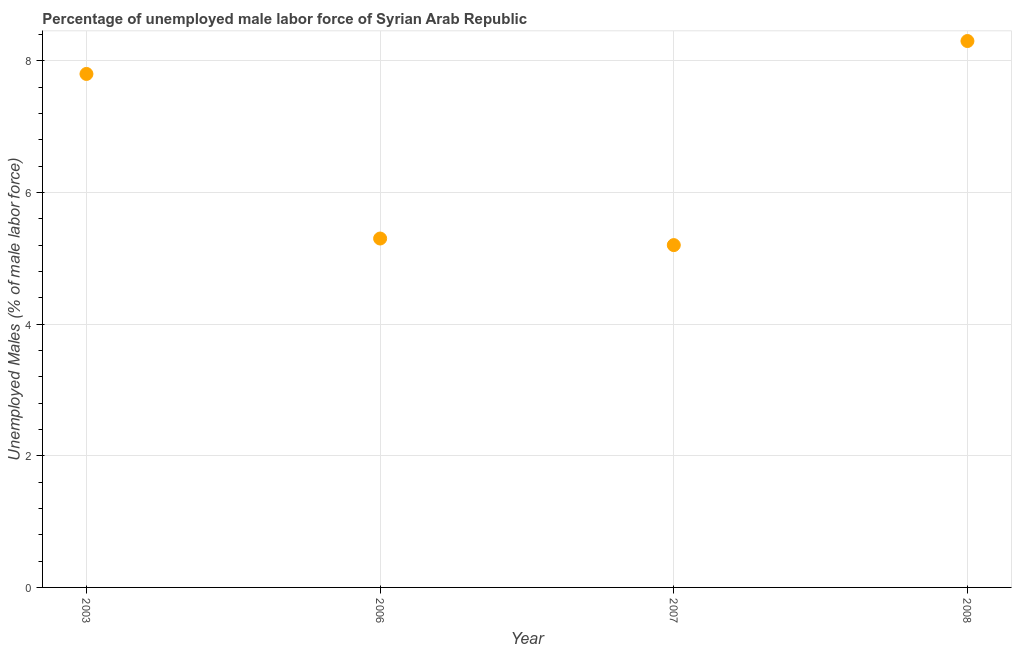What is the total unemployed male labour force in 2008?
Provide a short and direct response. 8.3. Across all years, what is the maximum total unemployed male labour force?
Keep it short and to the point. 8.3. Across all years, what is the minimum total unemployed male labour force?
Ensure brevity in your answer.  5.2. In which year was the total unemployed male labour force maximum?
Keep it short and to the point. 2008. In which year was the total unemployed male labour force minimum?
Give a very brief answer. 2007. What is the sum of the total unemployed male labour force?
Ensure brevity in your answer.  26.6. What is the difference between the total unemployed male labour force in 2003 and 2007?
Your answer should be compact. 2.6. What is the average total unemployed male labour force per year?
Give a very brief answer. 6.65. What is the median total unemployed male labour force?
Give a very brief answer. 6.55. What is the ratio of the total unemployed male labour force in 2006 to that in 2008?
Your answer should be compact. 0.64. What is the difference between the highest and the second highest total unemployed male labour force?
Your response must be concise. 0.5. What is the difference between the highest and the lowest total unemployed male labour force?
Ensure brevity in your answer.  3.1. In how many years, is the total unemployed male labour force greater than the average total unemployed male labour force taken over all years?
Keep it short and to the point. 2. How many dotlines are there?
Provide a succinct answer. 1. What is the difference between two consecutive major ticks on the Y-axis?
Ensure brevity in your answer.  2. Does the graph contain grids?
Provide a succinct answer. Yes. What is the title of the graph?
Provide a succinct answer. Percentage of unemployed male labor force of Syrian Arab Republic. What is the label or title of the X-axis?
Your answer should be compact. Year. What is the label or title of the Y-axis?
Your response must be concise. Unemployed Males (% of male labor force). What is the Unemployed Males (% of male labor force) in 2003?
Ensure brevity in your answer.  7.8. What is the Unemployed Males (% of male labor force) in 2006?
Make the answer very short. 5.3. What is the Unemployed Males (% of male labor force) in 2007?
Give a very brief answer. 5.2. What is the Unemployed Males (% of male labor force) in 2008?
Offer a very short reply. 8.3. What is the difference between the Unemployed Males (% of male labor force) in 2003 and 2006?
Your answer should be very brief. 2.5. What is the difference between the Unemployed Males (% of male labor force) in 2003 and 2007?
Make the answer very short. 2.6. What is the difference between the Unemployed Males (% of male labor force) in 2003 and 2008?
Your response must be concise. -0.5. What is the difference between the Unemployed Males (% of male labor force) in 2006 and 2008?
Your answer should be compact. -3. What is the difference between the Unemployed Males (% of male labor force) in 2007 and 2008?
Your response must be concise. -3.1. What is the ratio of the Unemployed Males (% of male labor force) in 2003 to that in 2006?
Give a very brief answer. 1.47. What is the ratio of the Unemployed Males (% of male labor force) in 2006 to that in 2007?
Offer a very short reply. 1.02. What is the ratio of the Unemployed Males (% of male labor force) in 2006 to that in 2008?
Your response must be concise. 0.64. What is the ratio of the Unemployed Males (% of male labor force) in 2007 to that in 2008?
Make the answer very short. 0.63. 